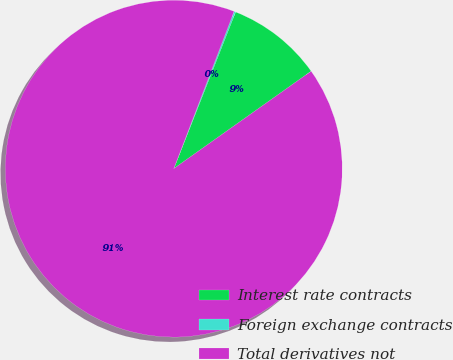Convert chart. <chart><loc_0><loc_0><loc_500><loc_500><pie_chart><fcel>Interest rate contracts<fcel>Foreign exchange contracts<fcel>Total derivatives not<nl><fcel>9.2%<fcel>0.15%<fcel>90.65%<nl></chart> 